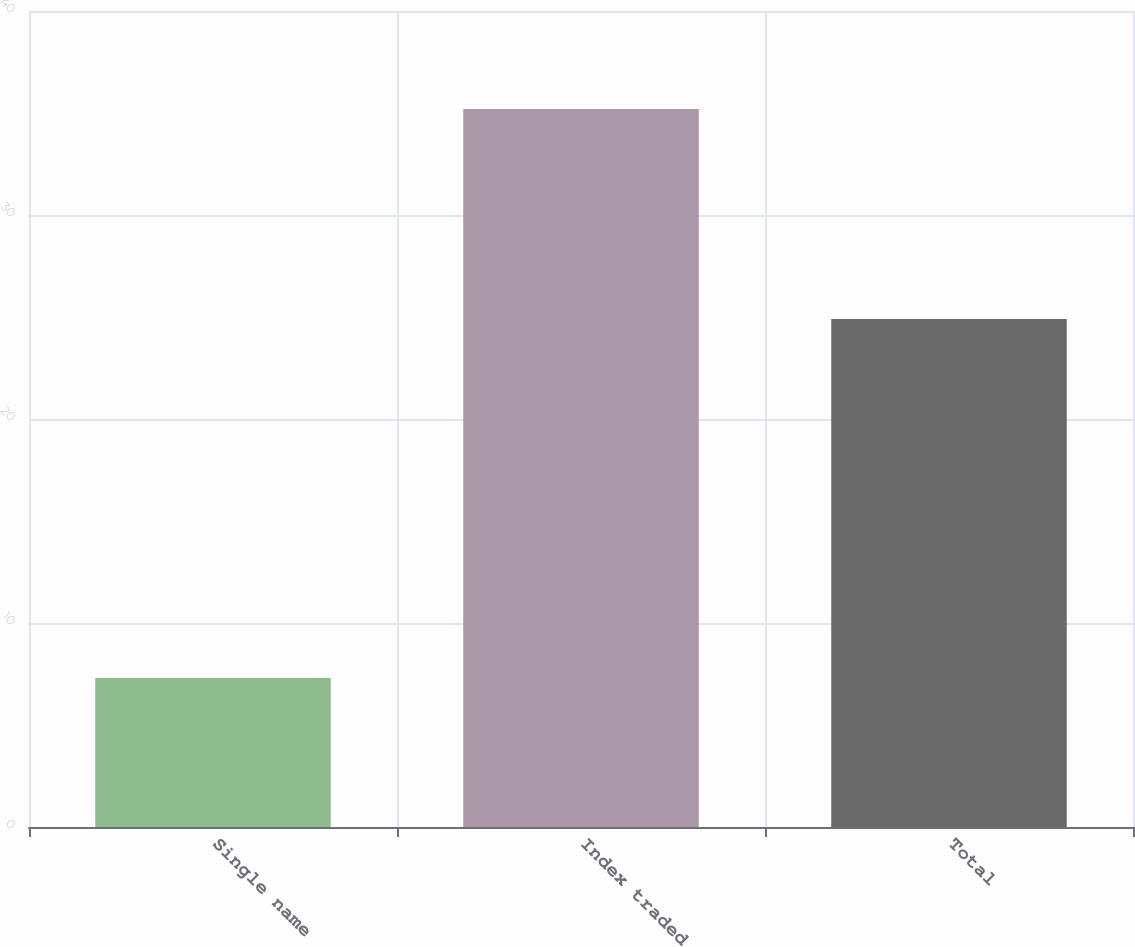Convert chart to OTSL. <chart><loc_0><loc_0><loc_500><loc_500><bar_chart><fcel>Single name<fcel>Index traded<fcel>Total<nl><fcel>7.3<fcel>35.2<fcel>24.9<nl></chart> 